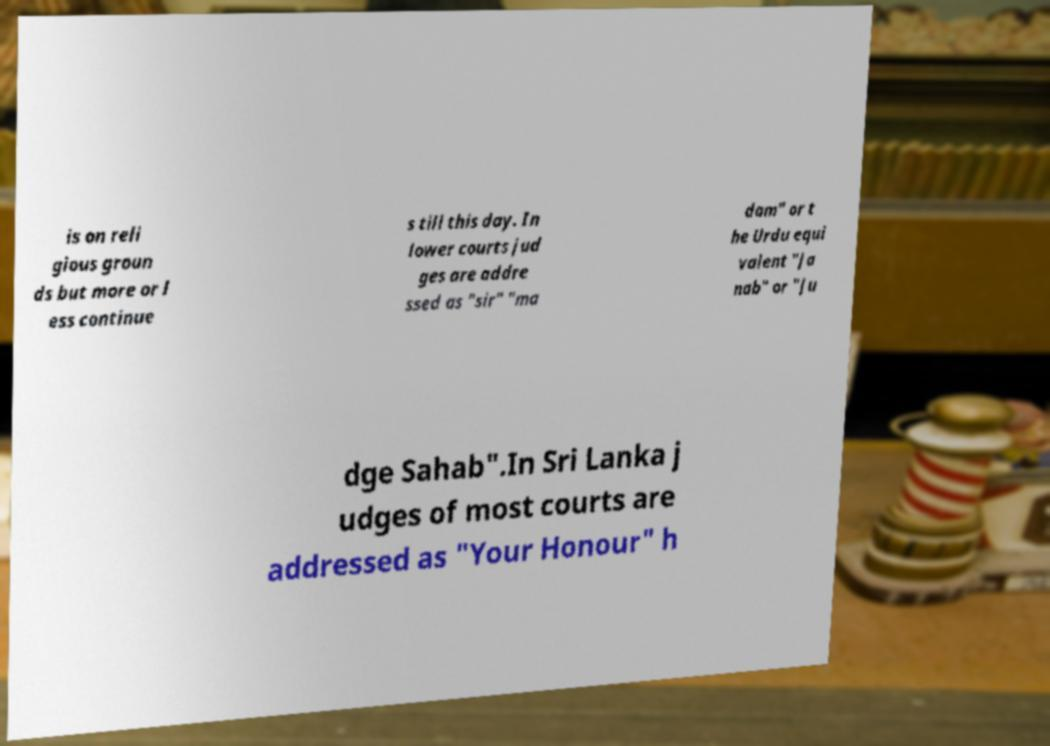Please identify and transcribe the text found in this image. is on reli gious groun ds but more or l ess continue s till this day. In lower courts jud ges are addre ssed as "sir" "ma dam" or t he Urdu equi valent "Ja nab" or "Ju dge Sahab".In Sri Lanka j udges of most courts are addressed as "Your Honour" h 